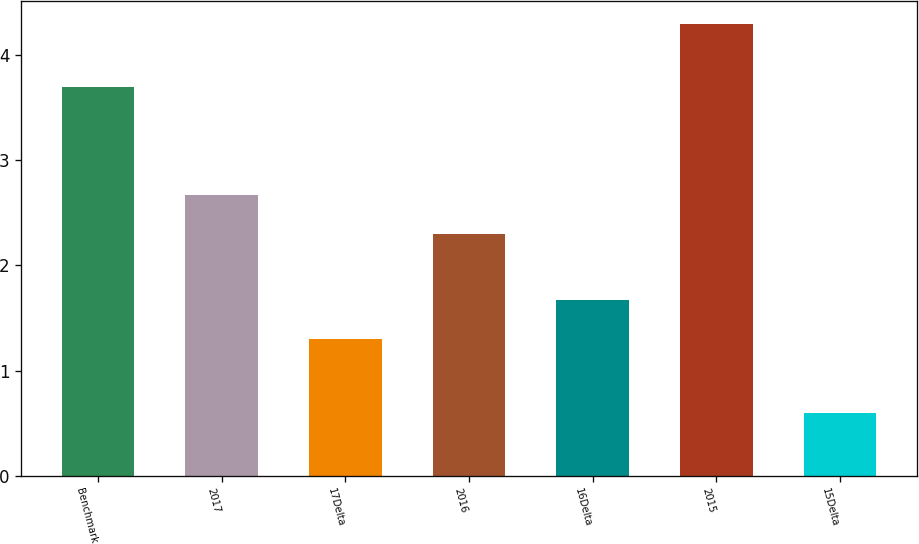Convert chart. <chart><loc_0><loc_0><loc_500><loc_500><bar_chart><fcel>Benchmark<fcel>2017<fcel>17Delta<fcel>2016<fcel>16Delta<fcel>2015<fcel>15Delta<nl><fcel>3.7<fcel>2.67<fcel>1.3<fcel>2.3<fcel>1.67<fcel>4.3<fcel>0.6<nl></chart> 